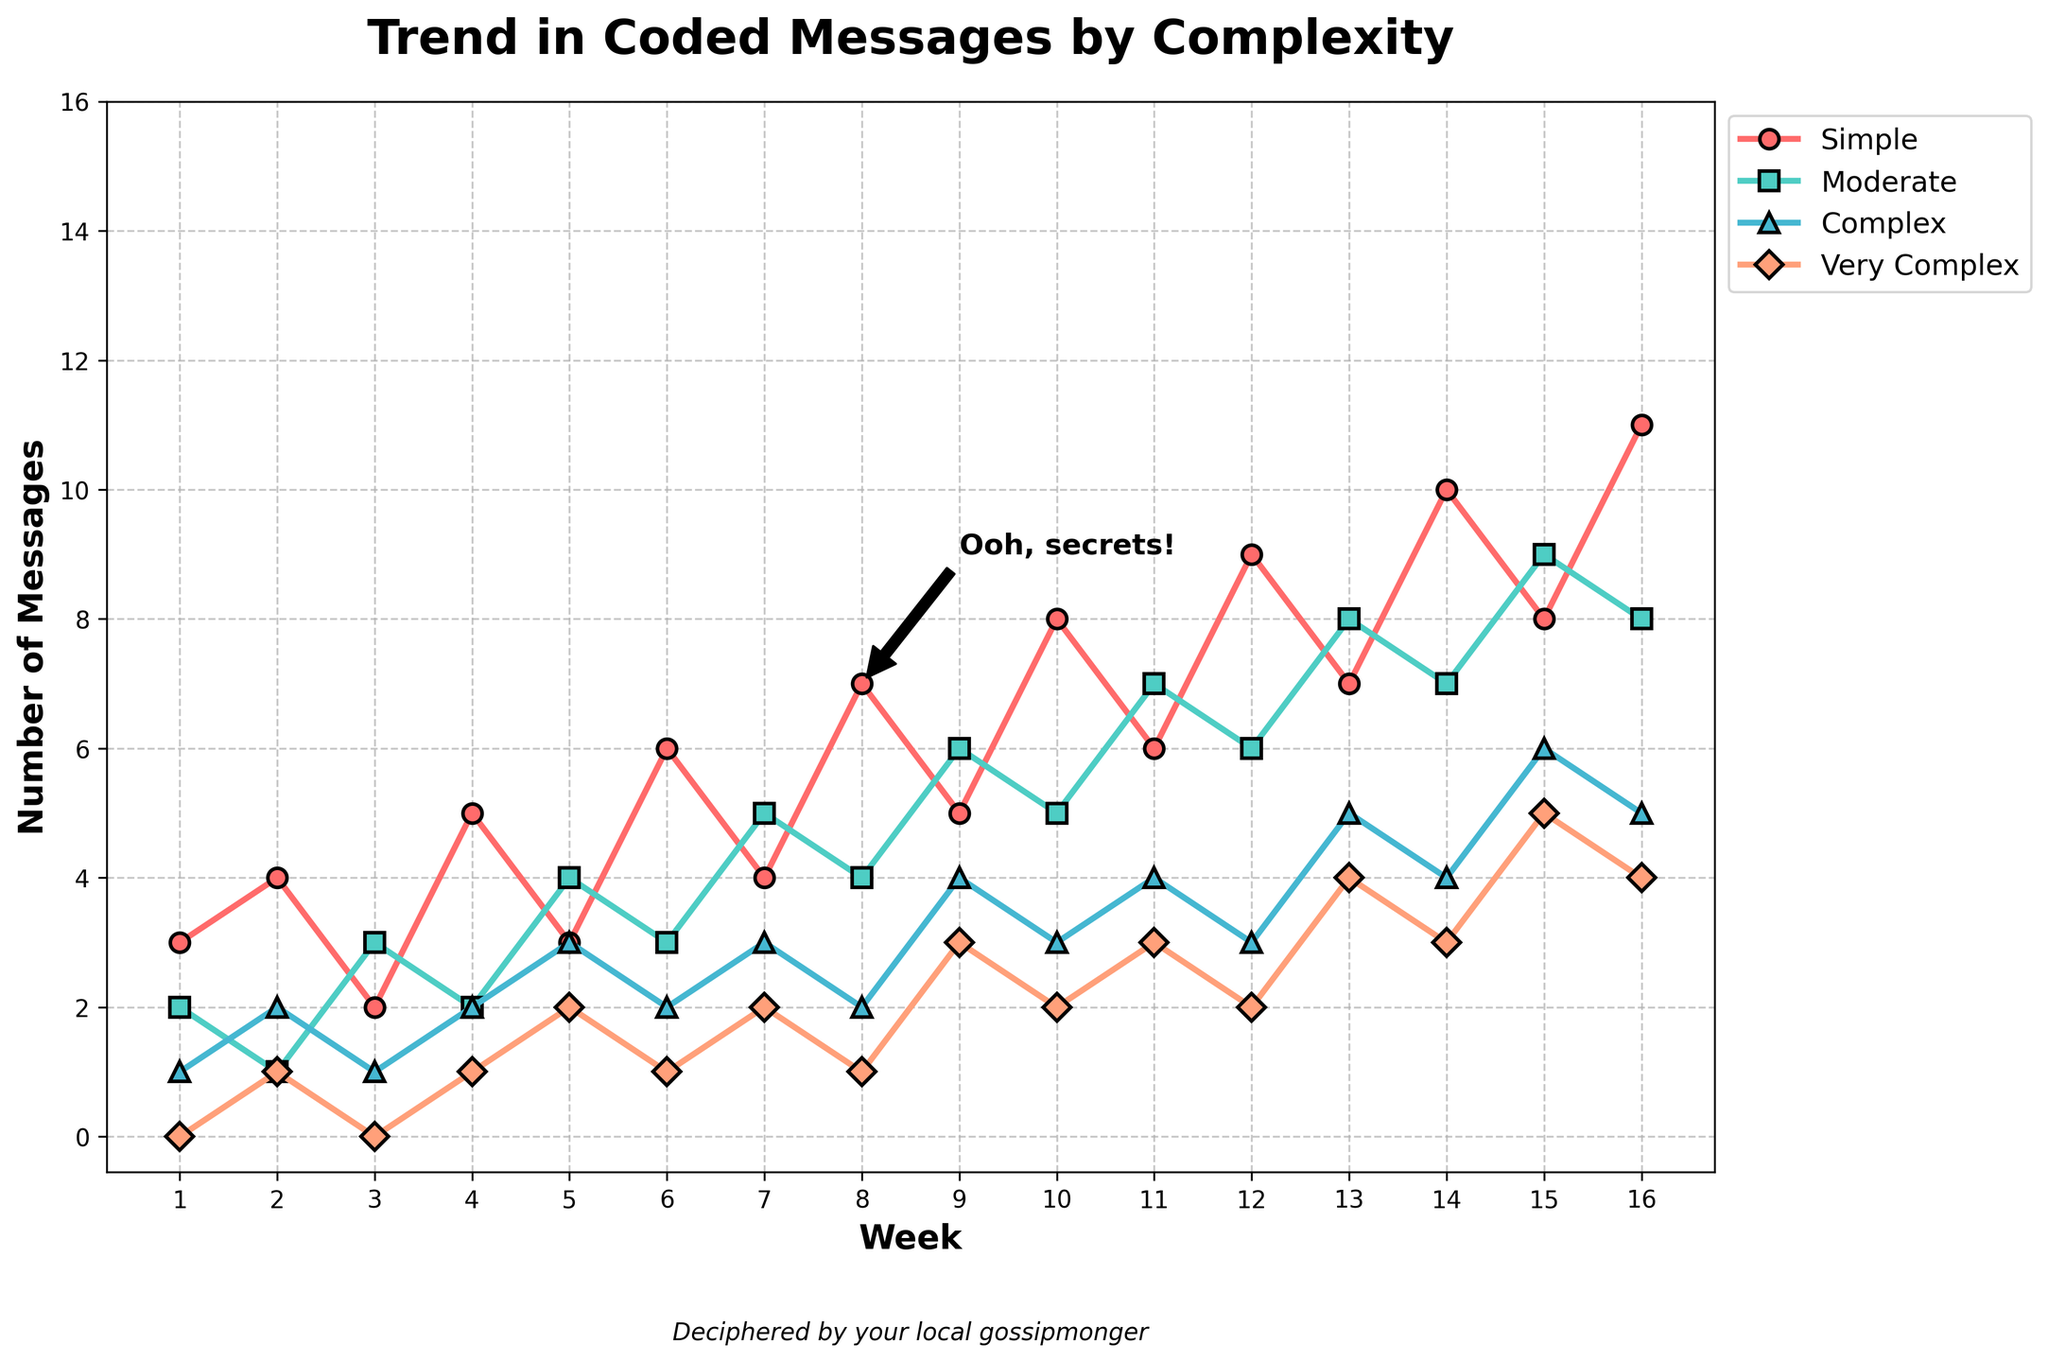What's the predominant trend for 'Simple' coded messages over 16 weeks? The 'Simple' line generally moves upward, starting at 3 messages and ending at 11 messages. The number of 'Simple' messages increases consistently with minor fluctuations.
Answer: Increases Which week had the highest number of 'Very Complex' coded messages? To determine this, observe the peaks of the 'Very Complex' line. The highest point for 'Very Complex' coded messages is at week 15, where the number reaches 5.
Answer: Week 15 Compare the trends of 'Moderate' and 'Complex' coded messages. Which one generally shows a higher count? Examine and compare the heights of the 'Moderate' and 'Complex' lines. The 'Moderate' line frequently appears above the 'Complex' line except for a few occasions. Hence, 'Moderate' messages generally show a higher count.
Answer: Moderate Add the number of 'Simple' and 'Very Complex' coded messages in Week 8. What is the sum? For Week 8, the 'Simple' messages are 7 and the 'Very Complex' messages are 1. Summing these values gives 7 + 1 = 8.
Answer: 8 Between weeks 10 and 12, how did the count of 'Complex' messages change? Observe the 'Complex' line between weeks 10 and 12. At week 10, the count is 3. It remains 3 at week 11 and also at week 12. Hence, the number of 'Complex' messages is unchanged.
Answer: No change What is the difference in the number of 'Moderate' coded messages between Week 16 and Week 1? In Week 16, the 'Moderate' coded messages are 8, and in Week 1, they are 2. The difference is 8 - 2 = 6.
Answer: 6 Which complexity category exhibited the most significant increase from Week 1 to Week 16? Compare the initial and final points of all lines. 'Simple' coded messages increased from 3 to 11, a net increase of 8; 'Moderate' increased from 2 to 8, a net increase of 6; 'Complex' increased from 1 to 5, a net increase of 4; 'Very Complex' increased from 0 to 4, a net increase of 4. The most significant increase is in the 'Simple' category.
Answer: Simple Estimate the approximate week when 'Moderate' coded messages surpassed 'Complex' coded messages for the first time. Check where the 'Moderate' line first goes above the 'Complex' line. This occurs around week 2, when 'Moderate' counts 1 surpassing 'Complex' counts 1 with 1 extra message.
Answer: Week 2 What is the combined total of the 'Simple', 'Moderate', and 'Very Complex' messages in Week 4? For Week 4, 'Simple' = 5, 'Moderate' = 2, 'Very Complex' = 1. The combined total is 5 + 2 + 1 = 8.
Answer: 8 How did the total number of coded messages change from Week 1 to Week 9? For Week 1: 3 (Simple) + 2 (Moderate) + 1 (Complex) + 0 (Very Complex) = 6. For Week 9: 5 (Simple) + 6 (Moderate) + 4 (Complex) + 3 (Very Complex) = 18. The total number increased by 18 - 6 = 12.
Answer: Increased by 12 